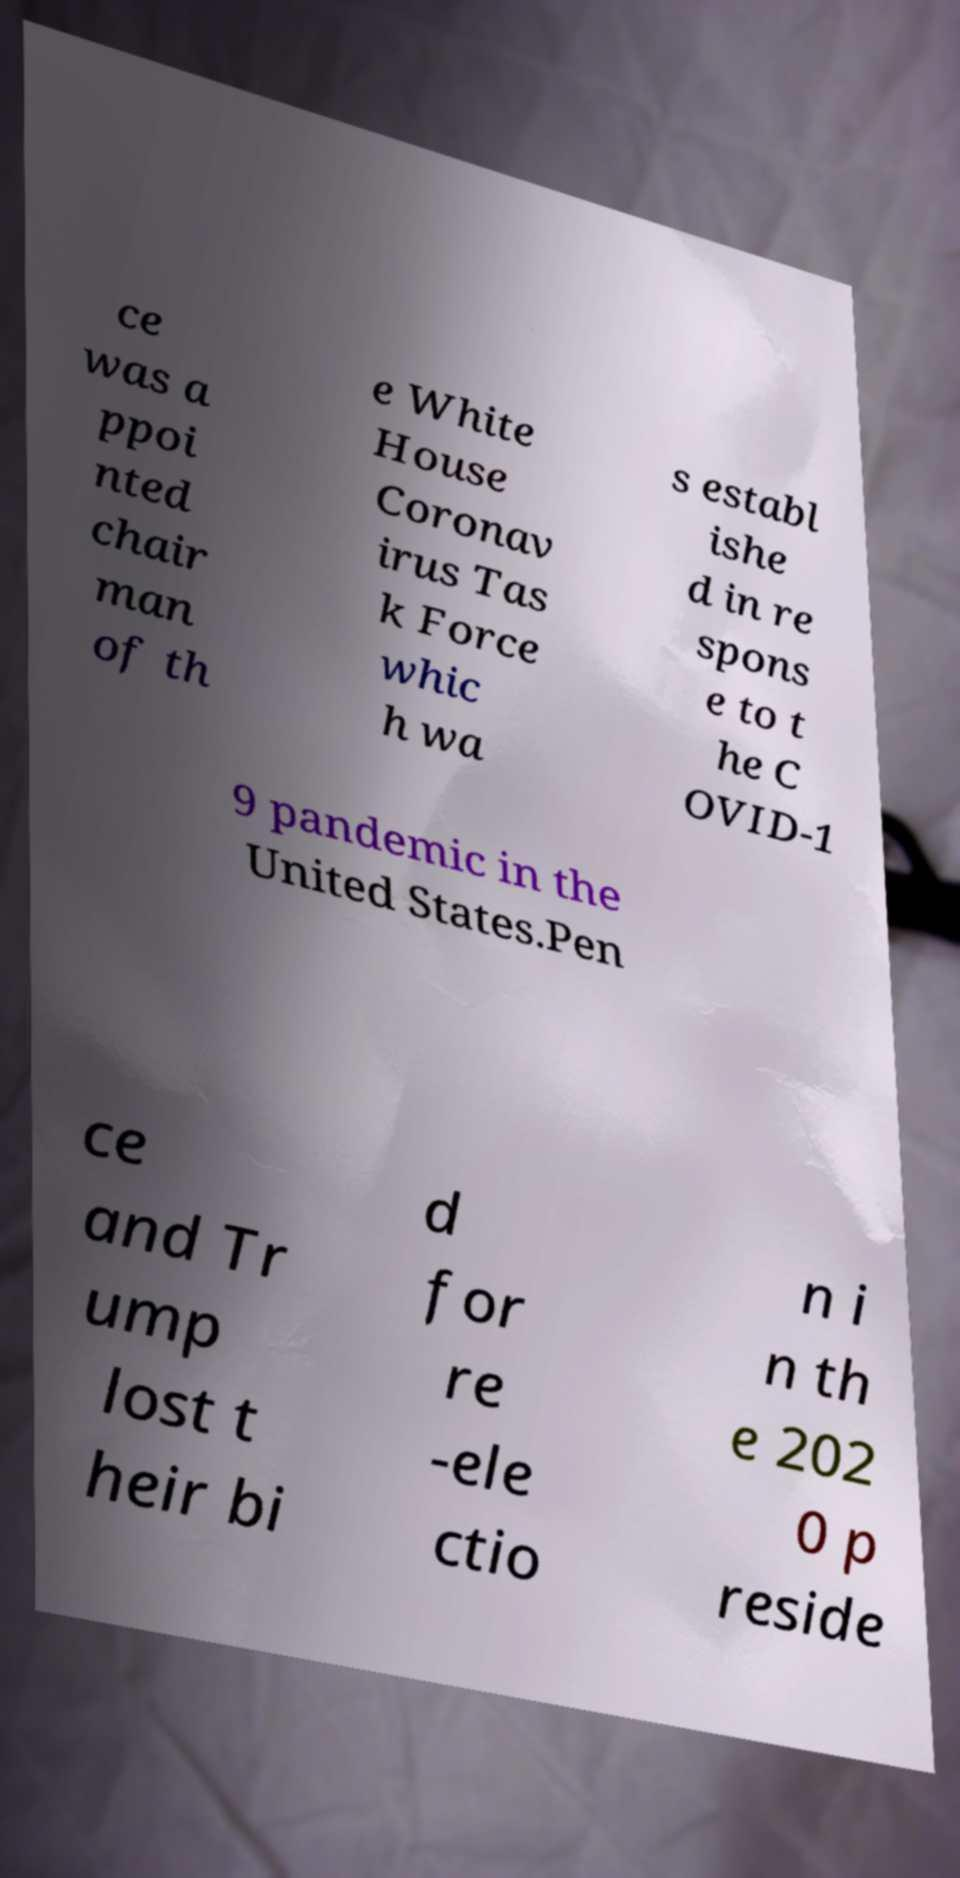Please read and relay the text visible in this image. What does it say? ce was a ppoi nted chair man of th e White House Coronav irus Tas k Force whic h wa s establ ishe d in re spons e to t he C OVID-1 9 pandemic in the United States.Pen ce and Tr ump lost t heir bi d for re -ele ctio n i n th e 202 0 p reside 